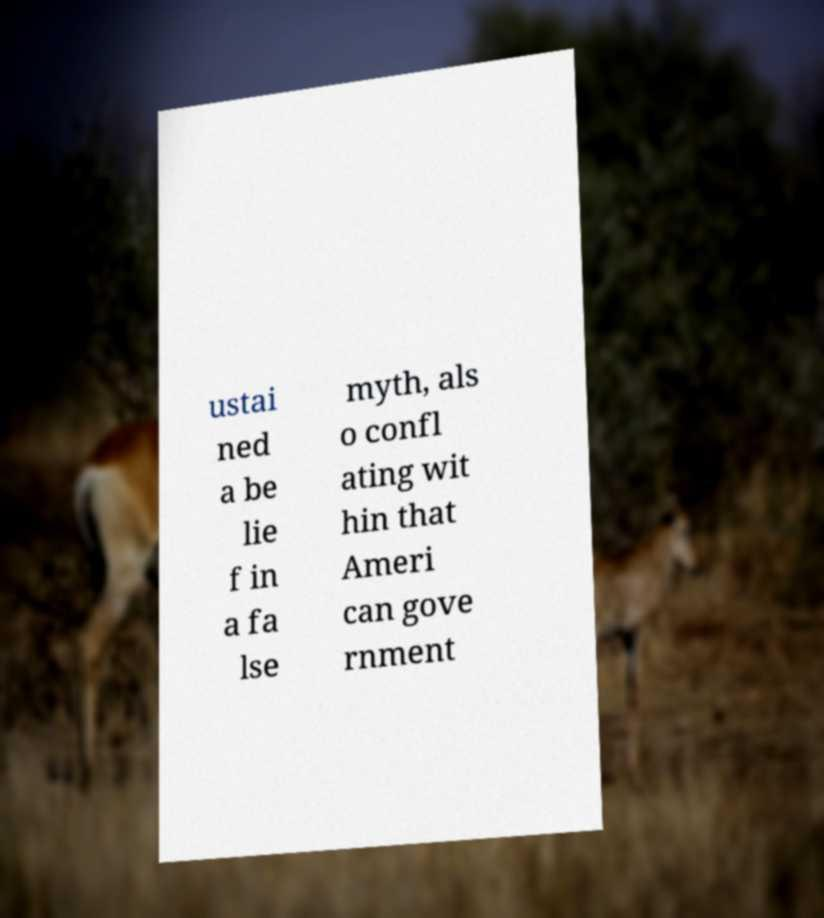Could you assist in decoding the text presented in this image and type it out clearly? ustai ned a be lie f in a fa lse myth, als o confl ating wit hin that Ameri can gove rnment 